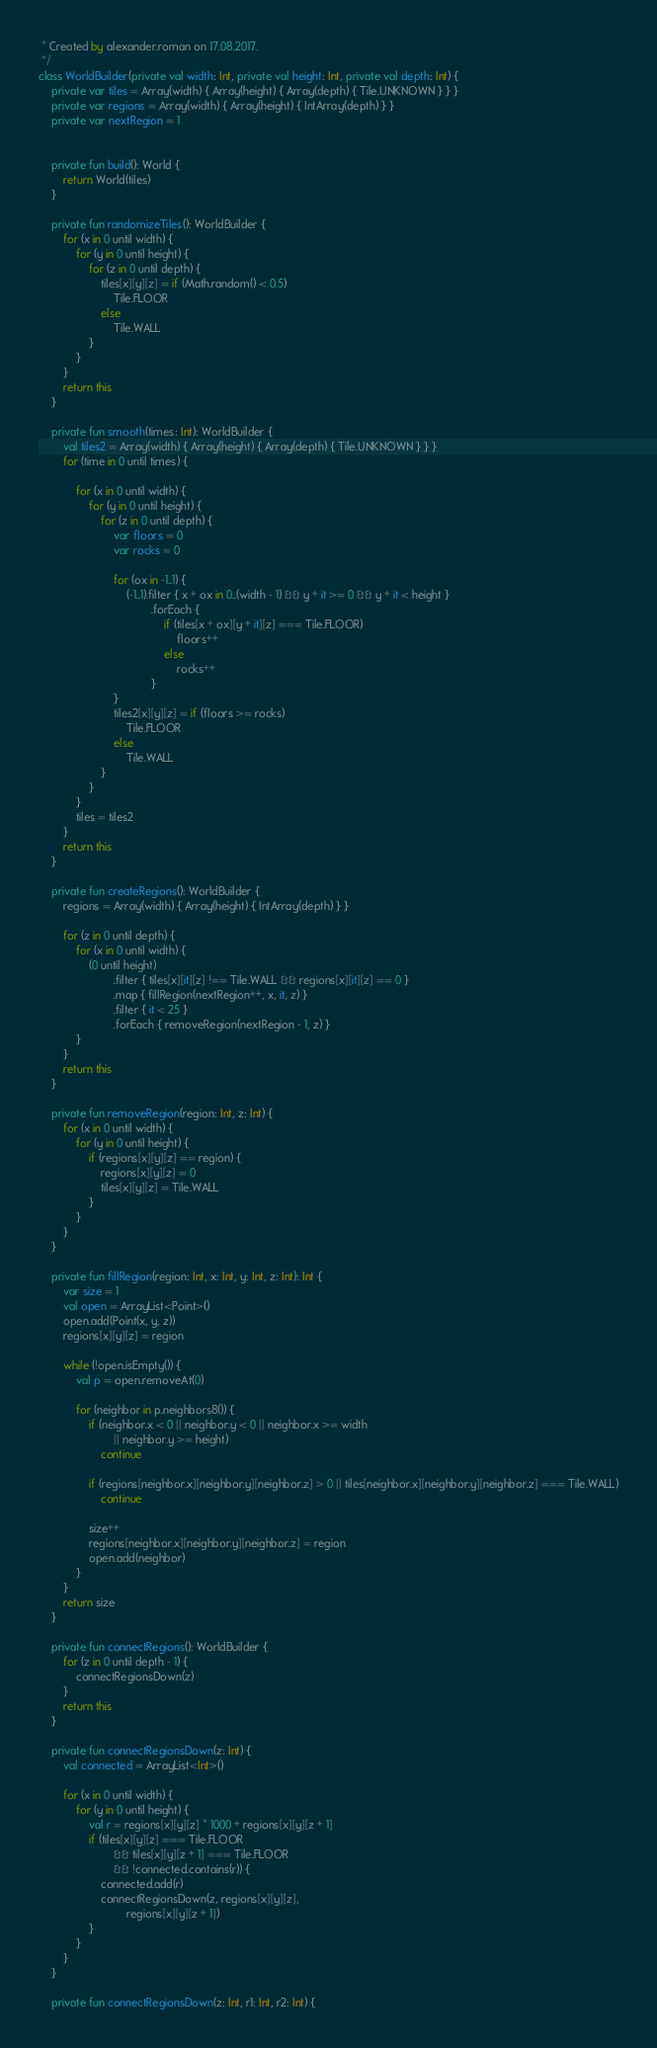<code> <loc_0><loc_0><loc_500><loc_500><_Kotlin_> * Created by alexander.roman on 17.08.2017.
 */
class WorldBuilder(private val width: Int, private val height: Int, private val depth: Int) {
    private var tiles = Array(width) { Array(height) { Array(depth) { Tile.UNKNOWN } } }
    private var regions = Array(width) { Array(height) { IntArray(depth) } }
    private var nextRegion = 1


    private fun build(): World {
        return World(tiles)
    }

    private fun randomizeTiles(): WorldBuilder {
        for (x in 0 until width) {
            for (y in 0 until height) {
                for (z in 0 until depth) {
                    tiles[x][y][z] = if (Math.random() < 0.5)
                        Tile.FLOOR
                    else
                        Tile.WALL
                }
            }
        }
        return this
    }

    private fun smooth(times: Int): WorldBuilder {
        val tiles2 = Array(width) { Array(height) { Array(depth) { Tile.UNKNOWN } } }
        for (time in 0 until times) {

            for (x in 0 until width) {
                for (y in 0 until height) {
                    for (z in 0 until depth) {
                        var floors = 0
                        var rocks = 0

                        for (ox in -1..1) {
                            (-1..1).filter { x + ox in 0..(width - 1) && y + it >= 0 && y + it < height }
                                    .forEach {
                                        if (tiles[x + ox][y + it][z] === Tile.FLOOR)
                                            floors++
                                        else
                                            rocks++
                                    }
                        }
                        tiles2[x][y][z] = if (floors >= rocks)
                            Tile.FLOOR
                        else
                            Tile.WALL
                    }
                }
            }
            tiles = tiles2
        }
        return this
    }

    private fun createRegions(): WorldBuilder {
        regions = Array(width) { Array(height) { IntArray(depth) } }

        for (z in 0 until depth) {
            for (x in 0 until width) {
                (0 until height)
                        .filter { tiles[x][it][z] !== Tile.WALL && regions[x][it][z] == 0 }
                        .map { fillRegion(nextRegion++, x, it, z) }
                        .filter { it < 25 }
                        .forEach { removeRegion(nextRegion - 1, z) }
            }
        }
        return this
    }

    private fun removeRegion(region: Int, z: Int) {
        for (x in 0 until width) {
            for (y in 0 until height) {
                if (regions[x][y][z] == region) {
                    regions[x][y][z] = 0
                    tiles[x][y][z] = Tile.WALL
                }
            }
        }
    }

    private fun fillRegion(region: Int, x: Int, y: Int, z: Int): Int {
        var size = 1
        val open = ArrayList<Point>()
        open.add(Point(x, y, z))
        regions[x][y][z] = region

        while (!open.isEmpty()) {
            val p = open.removeAt(0)

            for (neighbor in p.neighbors8()) {
                if (neighbor.x < 0 || neighbor.y < 0 || neighbor.x >= width
                        || neighbor.y >= height)
                    continue

                if (regions[neighbor.x][neighbor.y][neighbor.z] > 0 || tiles[neighbor.x][neighbor.y][neighbor.z] === Tile.WALL)
                    continue

                size++
                regions[neighbor.x][neighbor.y][neighbor.z] = region
                open.add(neighbor)
            }
        }
        return size
    }

    private fun connectRegions(): WorldBuilder {
        for (z in 0 until depth - 1) {
            connectRegionsDown(z)
        }
        return this
    }

    private fun connectRegionsDown(z: Int) {
        val connected = ArrayList<Int>()

        for (x in 0 until width) {
            for (y in 0 until height) {
                val r = regions[x][y][z] * 1000 + regions[x][y][z + 1]
                if (tiles[x][y][z] === Tile.FLOOR
                        && tiles[x][y][z + 1] === Tile.FLOOR
                        && !connected.contains(r)) {
                    connected.add(r)
                    connectRegionsDown(z, regions[x][y][z],
                            regions[x][y][z + 1])
                }
            }
        }
    }

    private fun connectRegionsDown(z: Int, r1: Int, r2: Int) {</code> 